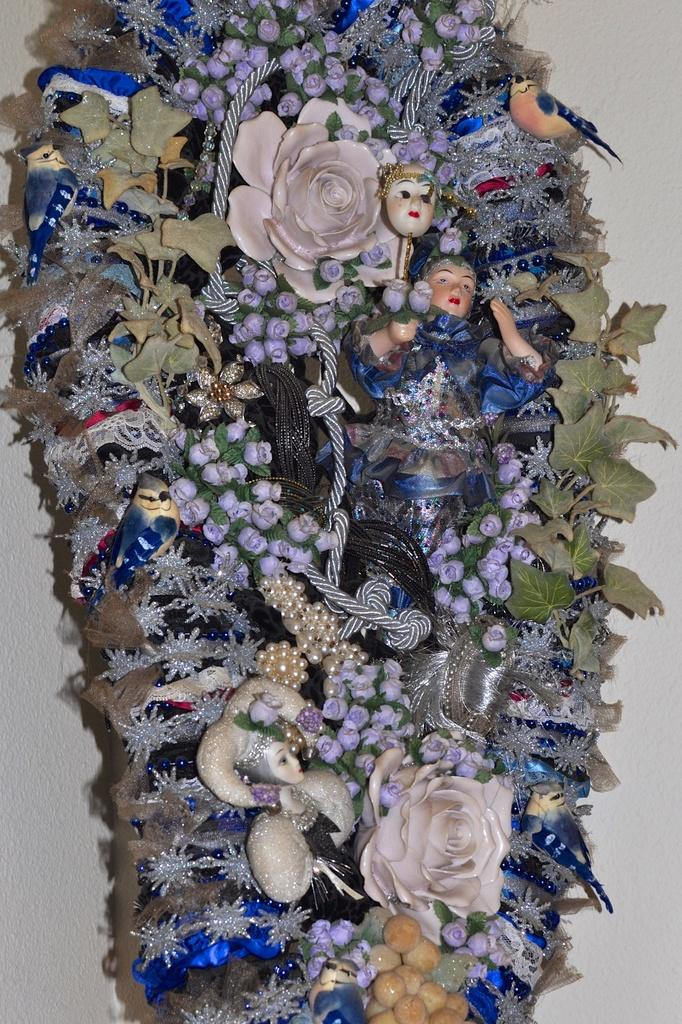What is the main subject of the image that appears to be truncated? The facts provided do not specify the main subject of the image, only that it appears to be truncated. What can be seen in the background of the image? There is a wall in the background of the image. How many fingers can be seen on the object in the image? There is no mention of fingers or any object that would have fingers in the image. 